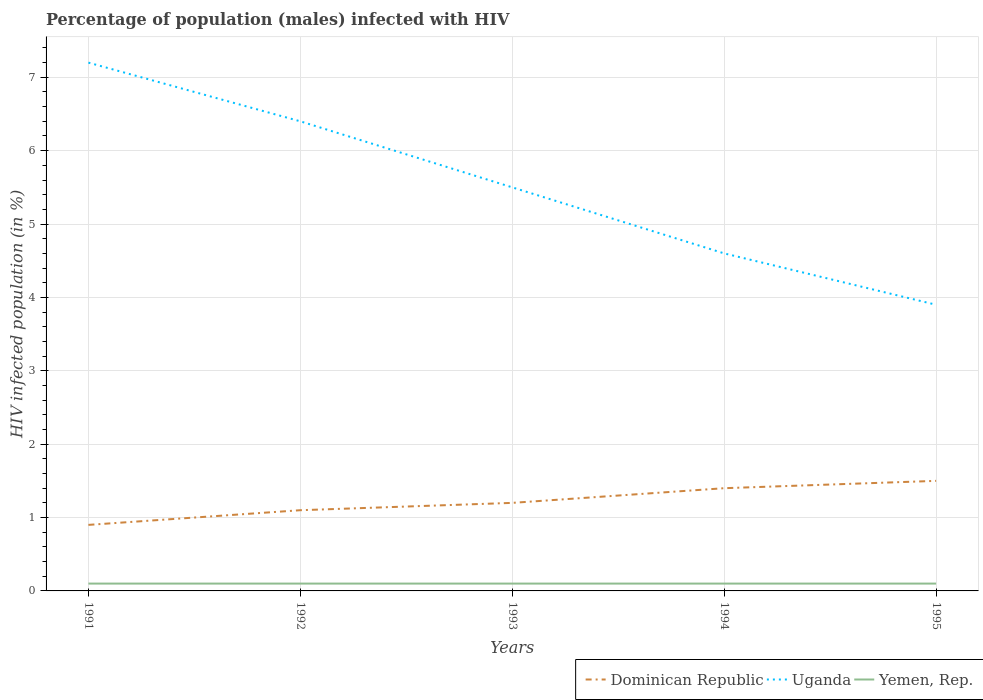Across all years, what is the maximum percentage of HIV infected male population in Uganda?
Offer a terse response. 3.9. In which year was the percentage of HIV infected male population in Uganda maximum?
Provide a short and direct response. 1995. What is the difference between the highest and the lowest percentage of HIV infected male population in Uganda?
Your answer should be compact. 2. How many lines are there?
Offer a terse response. 3. Are the values on the major ticks of Y-axis written in scientific E-notation?
Give a very brief answer. No. Does the graph contain any zero values?
Your answer should be very brief. No. Does the graph contain grids?
Give a very brief answer. Yes. Where does the legend appear in the graph?
Keep it short and to the point. Bottom right. How many legend labels are there?
Offer a terse response. 3. How are the legend labels stacked?
Offer a very short reply. Horizontal. What is the title of the graph?
Ensure brevity in your answer.  Percentage of population (males) infected with HIV. Does "Ireland" appear as one of the legend labels in the graph?
Provide a succinct answer. No. What is the label or title of the Y-axis?
Offer a very short reply. HIV infected population (in %). What is the HIV infected population (in %) in Dominican Republic in 1991?
Provide a succinct answer. 0.9. What is the HIV infected population (in %) of Yemen, Rep. in 1991?
Make the answer very short. 0.1. What is the HIV infected population (in %) of Yemen, Rep. in 1992?
Provide a short and direct response. 0.1. What is the HIV infected population (in %) of Dominican Republic in 1993?
Your answer should be very brief. 1.2. What is the HIV infected population (in %) of Uganda in 1993?
Offer a very short reply. 5.5. What is the HIV infected population (in %) of Yemen, Rep. in 1994?
Your answer should be very brief. 0.1. What is the HIV infected population (in %) in Dominican Republic in 1995?
Offer a terse response. 1.5. What is the HIV infected population (in %) of Yemen, Rep. in 1995?
Offer a terse response. 0.1. Across all years, what is the maximum HIV infected population (in %) in Yemen, Rep.?
Offer a terse response. 0.1. Across all years, what is the minimum HIV infected population (in %) in Uganda?
Ensure brevity in your answer.  3.9. What is the total HIV infected population (in %) of Dominican Republic in the graph?
Offer a very short reply. 6.1. What is the total HIV infected population (in %) of Uganda in the graph?
Provide a short and direct response. 27.6. What is the total HIV infected population (in %) in Yemen, Rep. in the graph?
Your answer should be compact. 0.5. What is the difference between the HIV infected population (in %) in Dominican Republic in 1991 and that in 1992?
Offer a terse response. -0.2. What is the difference between the HIV infected population (in %) of Uganda in 1991 and that in 1992?
Your answer should be very brief. 0.8. What is the difference between the HIV infected population (in %) of Yemen, Rep. in 1991 and that in 1992?
Provide a succinct answer. 0. What is the difference between the HIV infected population (in %) of Uganda in 1991 and that in 1993?
Keep it short and to the point. 1.7. What is the difference between the HIV infected population (in %) in Dominican Republic in 1991 and that in 1994?
Ensure brevity in your answer.  -0.5. What is the difference between the HIV infected population (in %) in Uganda in 1991 and that in 1994?
Offer a terse response. 2.6. What is the difference between the HIV infected population (in %) in Yemen, Rep. in 1991 and that in 1994?
Ensure brevity in your answer.  0. What is the difference between the HIV infected population (in %) of Dominican Republic in 1991 and that in 1995?
Provide a succinct answer. -0.6. What is the difference between the HIV infected population (in %) of Yemen, Rep. in 1991 and that in 1995?
Your answer should be very brief. 0. What is the difference between the HIV infected population (in %) in Dominican Republic in 1992 and that in 1993?
Make the answer very short. -0.1. What is the difference between the HIV infected population (in %) of Uganda in 1992 and that in 1993?
Offer a very short reply. 0.9. What is the difference between the HIV infected population (in %) of Yemen, Rep. in 1992 and that in 1993?
Give a very brief answer. 0. What is the difference between the HIV infected population (in %) of Dominican Republic in 1992 and that in 1994?
Provide a short and direct response. -0.3. What is the difference between the HIV infected population (in %) in Yemen, Rep. in 1992 and that in 1995?
Keep it short and to the point. 0. What is the difference between the HIV infected population (in %) of Yemen, Rep. in 1993 and that in 1994?
Keep it short and to the point. 0. What is the difference between the HIV infected population (in %) in Yemen, Rep. in 1994 and that in 1995?
Provide a short and direct response. 0. What is the difference between the HIV infected population (in %) of Dominican Republic in 1991 and the HIV infected population (in %) of Yemen, Rep. in 1992?
Your answer should be compact. 0.8. What is the difference between the HIV infected population (in %) of Dominican Republic in 1991 and the HIV infected population (in %) of Yemen, Rep. in 1993?
Provide a succinct answer. 0.8. What is the difference between the HIV infected population (in %) in Dominican Republic in 1991 and the HIV infected population (in %) in Uganda in 1994?
Provide a succinct answer. -3.7. What is the difference between the HIV infected population (in %) of Dominican Republic in 1991 and the HIV infected population (in %) of Yemen, Rep. in 1994?
Provide a succinct answer. 0.8. What is the difference between the HIV infected population (in %) of Uganda in 1991 and the HIV infected population (in %) of Yemen, Rep. in 1994?
Provide a succinct answer. 7.1. What is the difference between the HIV infected population (in %) in Dominican Republic in 1991 and the HIV infected population (in %) in Yemen, Rep. in 1995?
Provide a succinct answer. 0.8. What is the difference between the HIV infected population (in %) of Dominican Republic in 1992 and the HIV infected population (in %) of Uganda in 1993?
Your response must be concise. -4.4. What is the difference between the HIV infected population (in %) in Uganda in 1992 and the HIV infected population (in %) in Yemen, Rep. in 1993?
Provide a short and direct response. 6.3. What is the difference between the HIV infected population (in %) in Dominican Republic in 1992 and the HIV infected population (in %) in Uganda in 1994?
Your response must be concise. -3.5. What is the difference between the HIV infected population (in %) of Dominican Republic in 1992 and the HIV infected population (in %) of Yemen, Rep. in 1994?
Your response must be concise. 1. What is the difference between the HIV infected population (in %) of Uganda in 1992 and the HIV infected population (in %) of Yemen, Rep. in 1994?
Provide a short and direct response. 6.3. What is the difference between the HIV infected population (in %) in Dominican Republic in 1992 and the HIV infected population (in %) in Uganda in 1995?
Offer a terse response. -2.8. What is the difference between the HIV infected population (in %) in Dominican Republic in 1992 and the HIV infected population (in %) in Yemen, Rep. in 1995?
Provide a succinct answer. 1. What is the difference between the HIV infected population (in %) in Uganda in 1992 and the HIV infected population (in %) in Yemen, Rep. in 1995?
Your answer should be very brief. 6.3. What is the difference between the HIV infected population (in %) of Dominican Republic in 1993 and the HIV infected population (in %) of Uganda in 1995?
Offer a terse response. -2.7. What is the difference between the HIV infected population (in %) of Dominican Republic in 1993 and the HIV infected population (in %) of Yemen, Rep. in 1995?
Ensure brevity in your answer.  1.1. What is the difference between the HIV infected population (in %) in Dominican Republic in 1994 and the HIV infected population (in %) in Uganda in 1995?
Offer a terse response. -2.5. What is the difference between the HIV infected population (in %) in Dominican Republic in 1994 and the HIV infected population (in %) in Yemen, Rep. in 1995?
Offer a terse response. 1.3. What is the average HIV infected population (in %) in Dominican Republic per year?
Make the answer very short. 1.22. What is the average HIV infected population (in %) in Uganda per year?
Give a very brief answer. 5.52. What is the average HIV infected population (in %) in Yemen, Rep. per year?
Give a very brief answer. 0.1. In the year 1991, what is the difference between the HIV infected population (in %) in Dominican Republic and HIV infected population (in %) in Uganda?
Ensure brevity in your answer.  -6.3. In the year 1991, what is the difference between the HIV infected population (in %) in Uganda and HIV infected population (in %) in Yemen, Rep.?
Offer a terse response. 7.1. In the year 1992, what is the difference between the HIV infected population (in %) of Dominican Republic and HIV infected population (in %) of Yemen, Rep.?
Your answer should be compact. 1. In the year 1992, what is the difference between the HIV infected population (in %) of Uganda and HIV infected population (in %) of Yemen, Rep.?
Provide a short and direct response. 6.3. In the year 1993, what is the difference between the HIV infected population (in %) of Dominican Republic and HIV infected population (in %) of Yemen, Rep.?
Your answer should be compact. 1.1. In the year 1994, what is the difference between the HIV infected population (in %) of Uganda and HIV infected population (in %) of Yemen, Rep.?
Ensure brevity in your answer.  4.5. In the year 1995, what is the difference between the HIV infected population (in %) in Dominican Republic and HIV infected population (in %) in Uganda?
Give a very brief answer. -2.4. In the year 1995, what is the difference between the HIV infected population (in %) in Uganda and HIV infected population (in %) in Yemen, Rep.?
Make the answer very short. 3.8. What is the ratio of the HIV infected population (in %) of Dominican Republic in 1991 to that in 1992?
Offer a very short reply. 0.82. What is the ratio of the HIV infected population (in %) in Uganda in 1991 to that in 1992?
Provide a succinct answer. 1.12. What is the ratio of the HIV infected population (in %) of Yemen, Rep. in 1991 to that in 1992?
Provide a succinct answer. 1. What is the ratio of the HIV infected population (in %) in Dominican Republic in 1991 to that in 1993?
Your answer should be very brief. 0.75. What is the ratio of the HIV infected population (in %) of Uganda in 1991 to that in 1993?
Your answer should be very brief. 1.31. What is the ratio of the HIV infected population (in %) of Yemen, Rep. in 1991 to that in 1993?
Provide a short and direct response. 1. What is the ratio of the HIV infected population (in %) in Dominican Republic in 1991 to that in 1994?
Your response must be concise. 0.64. What is the ratio of the HIV infected population (in %) of Uganda in 1991 to that in 1994?
Offer a terse response. 1.57. What is the ratio of the HIV infected population (in %) of Uganda in 1991 to that in 1995?
Your answer should be compact. 1.85. What is the ratio of the HIV infected population (in %) of Uganda in 1992 to that in 1993?
Offer a very short reply. 1.16. What is the ratio of the HIV infected population (in %) of Dominican Republic in 1992 to that in 1994?
Offer a very short reply. 0.79. What is the ratio of the HIV infected population (in %) of Uganda in 1992 to that in 1994?
Your response must be concise. 1.39. What is the ratio of the HIV infected population (in %) of Yemen, Rep. in 1992 to that in 1994?
Ensure brevity in your answer.  1. What is the ratio of the HIV infected population (in %) of Dominican Republic in 1992 to that in 1995?
Your answer should be compact. 0.73. What is the ratio of the HIV infected population (in %) in Uganda in 1992 to that in 1995?
Offer a terse response. 1.64. What is the ratio of the HIV infected population (in %) of Yemen, Rep. in 1992 to that in 1995?
Your answer should be compact. 1. What is the ratio of the HIV infected population (in %) of Uganda in 1993 to that in 1994?
Offer a very short reply. 1.2. What is the ratio of the HIV infected population (in %) of Yemen, Rep. in 1993 to that in 1994?
Provide a short and direct response. 1. What is the ratio of the HIV infected population (in %) in Uganda in 1993 to that in 1995?
Your answer should be compact. 1.41. What is the ratio of the HIV infected population (in %) of Dominican Republic in 1994 to that in 1995?
Make the answer very short. 0.93. What is the ratio of the HIV infected population (in %) in Uganda in 1994 to that in 1995?
Your answer should be very brief. 1.18. What is the difference between the highest and the second highest HIV infected population (in %) in Uganda?
Your answer should be compact. 0.8. What is the difference between the highest and the lowest HIV infected population (in %) of Dominican Republic?
Provide a short and direct response. 0.6. What is the difference between the highest and the lowest HIV infected population (in %) in Yemen, Rep.?
Provide a short and direct response. 0. 